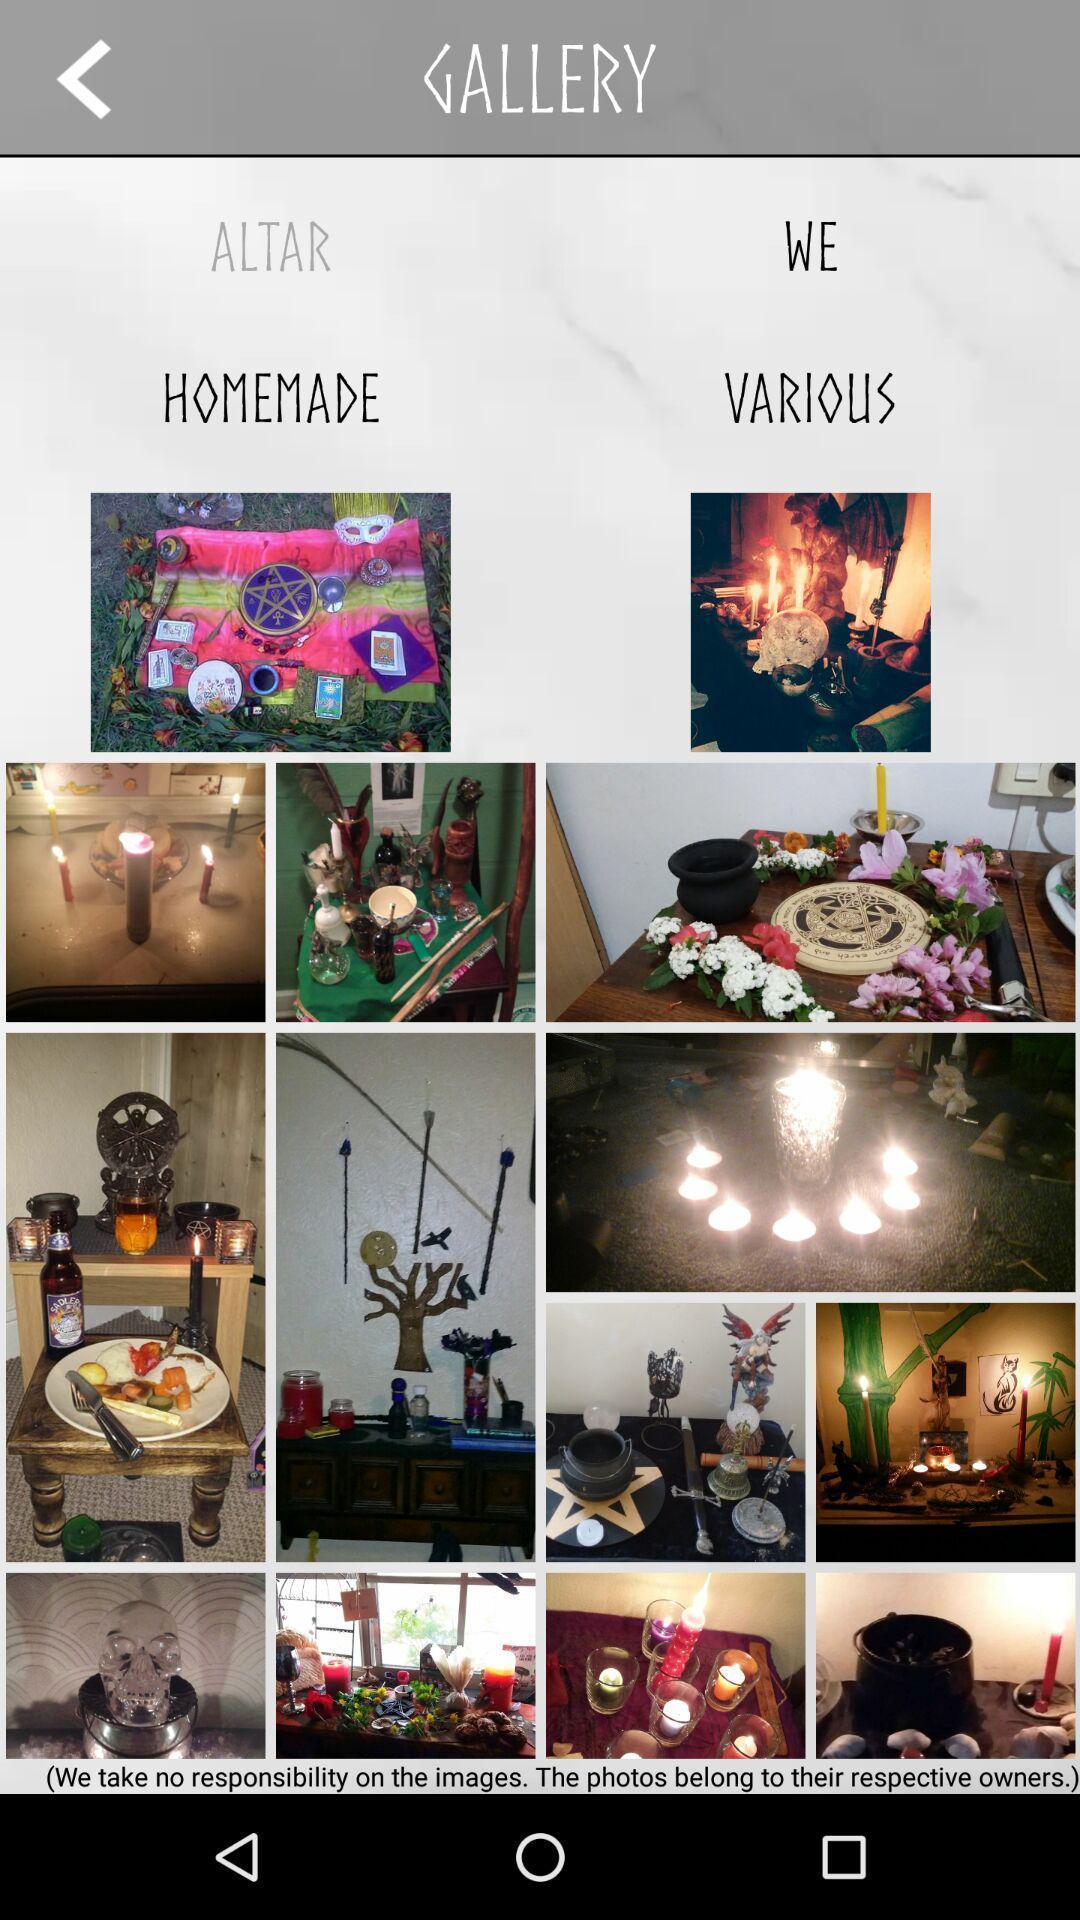Give me a summary of this screen capture. Page displaying various images. 